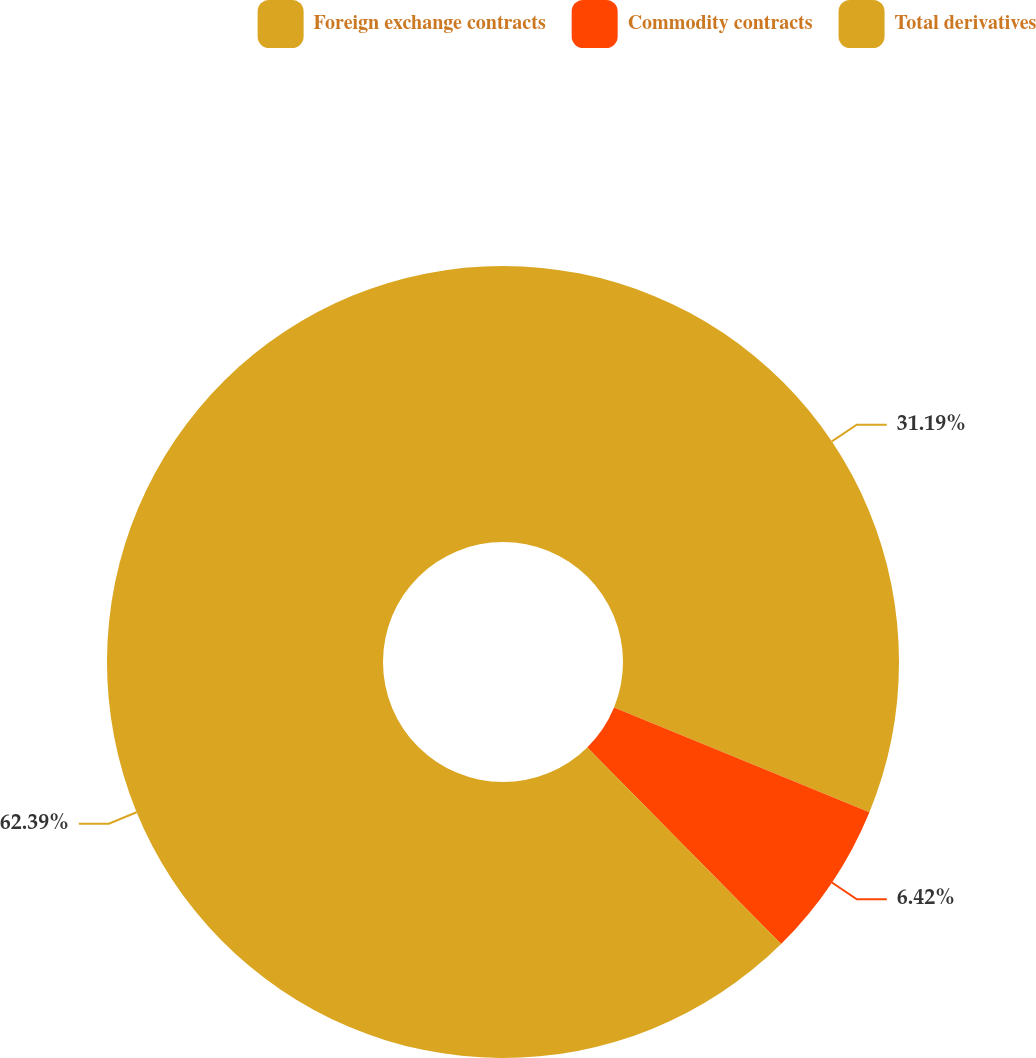<chart> <loc_0><loc_0><loc_500><loc_500><pie_chart><fcel>Foreign exchange contracts<fcel>Commodity contracts<fcel>Total derivatives<nl><fcel>31.19%<fcel>6.42%<fcel>62.39%<nl></chart> 